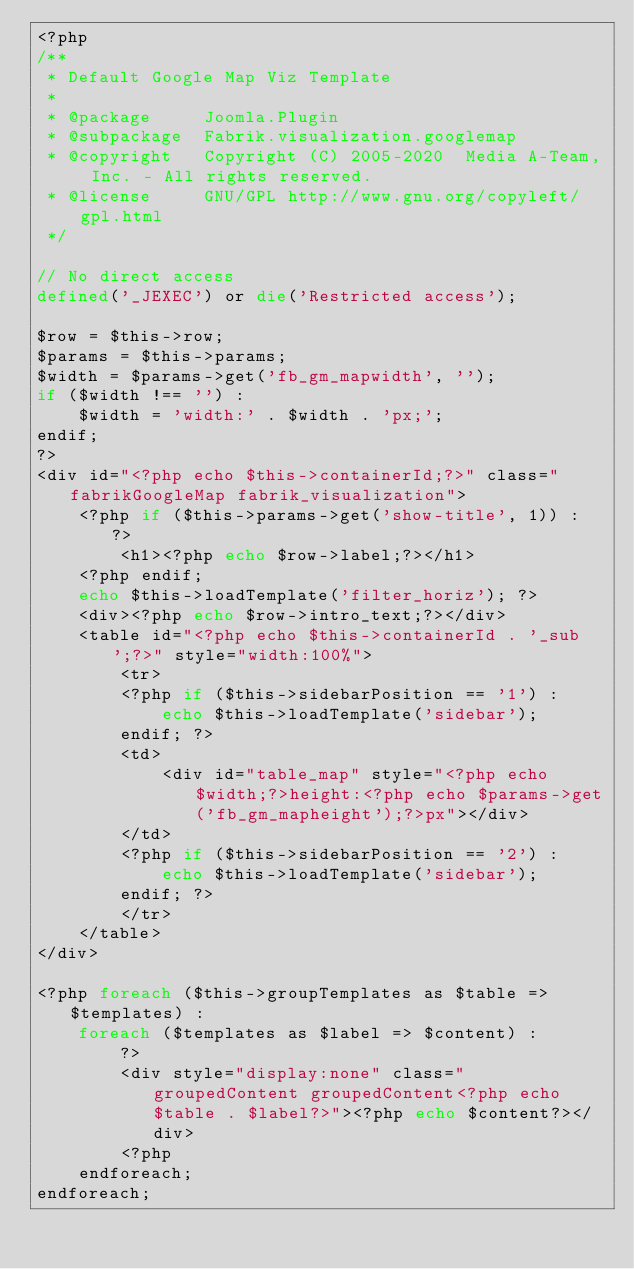<code> <loc_0><loc_0><loc_500><loc_500><_PHP_><?php
/**
 * Default Google Map Viz Template
 *
 * @package     Joomla.Plugin
 * @subpackage  Fabrik.visualization.googlemap
 * @copyright   Copyright (C) 2005-2020  Media A-Team, Inc. - All rights reserved.
 * @license     GNU/GPL http://www.gnu.org/copyleft/gpl.html
 */

// No direct access
defined('_JEXEC') or die('Restricted access');

$row = $this->row;
$params = $this->params;
$width = $params->get('fb_gm_mapwidth', '');
if ($width !== '') :
	$width = 'width:' . $width . 'px;';
endif;
?>
<div id="<?php echo $this->containerId;?>" class="fabrikGoogleMap fabrik_visualization">
	<?php if ($this->params->get('show-title', 1)) : ?>
		<h1><?php echo $row->label;?></h1>
	<?php endif;
	echo $this->loadTemplate('filter_horiz'); ?>
	<div><?php echo $row->intro_text;?></div>
	<table id="<?php echo $this->containerId . '_sub';?>" style="width:100%">
		<tr>
		<?php if ($this->sidebarPosition == '1') :
			echo $this->loadTemplate('sidebar');
		endif; ?>
		<td>
			<div id="table_map" style="<?php echo $width;?>height:<?php echo $params->get('fb_gm_mapheight');?>px"></div>
		</td>
		<?php if ($this->sidebarPosition == '2') :
			echo $this->loadTemplate('sidebar');
		endif; ?>
		</tr>
	</table>
</div>

<?php foreach ($this->groupTemplates as $table => $templates) :
	foreach ($templates as $label => $content) :
		?>
		<div style="display:none" class="groupedContent groupedContent<?php echo $table . $label?>"><?php echo $content?></div>
		<?php
	endforeach;
endforeach;
</code> 